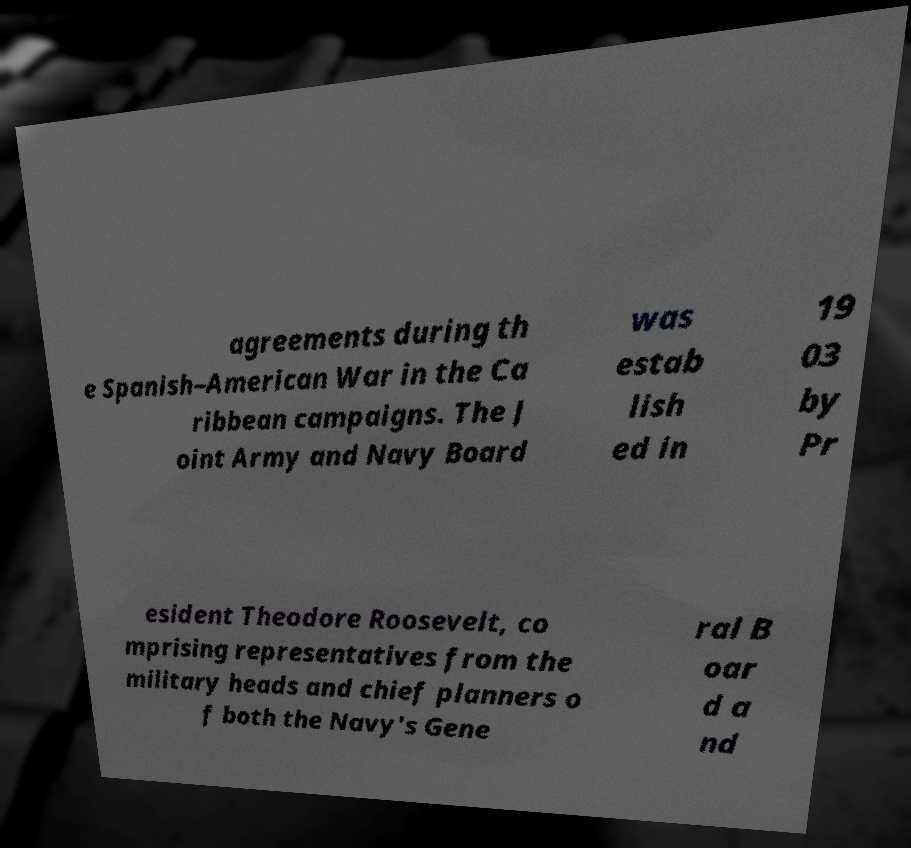Could you extract and type out the text from this image? agreements during th e Spanish–American War in the Ca ribbean campaigns. The J oint Army and Navy Board was estab lish ed in 19 03 by Pr esident Theodore Roosevelt, co mprising representatives from the military heads and chief planners o f both the Navy's Gene ral B oar d a nd 